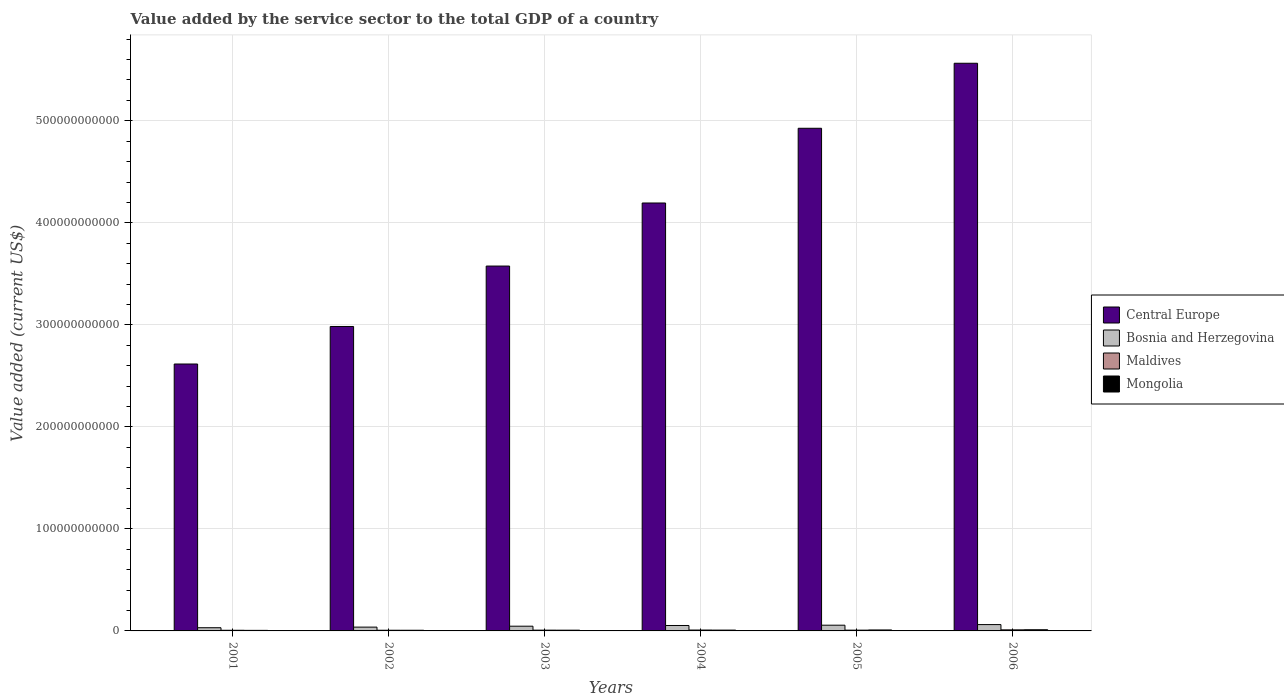How many groups of bars are there?
Your response must be concise. 6. Are the number of bars on each tick of the X-axis equal?
Your answer should be very brief. Yes. What is the label of the 6th group of bars from the left?
Give a very brief answer. 2006. What is the value added by the service sector to the total GDP in Bosnia and Herzegovina in 2003?
Your response must be concise. 4.64e+09. Across all years, what is the maximum value added by the service sector to the total GDP in Bosnia and Herzegovina?
Offer a very short reply. 6.21e+09. Across all years, what is the minimum value added by the service sector to the total GDP in Maldives?
Your response must be concise. 6.40e+08. What is the total value added by the service sector to the total GDP in Central Europe in the graph?
Your response must be concise. 2.39e+12. What is the difference between the value added by the service sector to the total GDP in Central Europe in 2003 and that in 2006?
Your response must be concise. -1.99e+11. What is the difference between the value added by the service sector to the total GDP in Central Europe in 2006 and the value added by the service sector to the total GDP in Mongolia in 2002?
Offer a very short reply. 5.56e+11. What is the average value added by the service sector to the total GDP in Bosnia and Herzegovina per year?
Your answer should be compact. 4.77e+09. In the year 2002, what is the difference between the value added by the service sector to the total GDP in Maldives and value added by the service sector to the total GDP in Mongolia?
Keep it short and to the point. 8.49e+06. In how many years, is the value added by the service sector to the total GDP in Maldives greater than 280000000000 US$?
Ensure brevity in your answer.  0. What is the ratio of the value added by the service sector to the total GDP in Maldives in 2003 to that in 2004?
Provide a succinct answer. 0.88. Is the value added by the service sector to the total GDP in Central Europe in 2005 less than that in 2006?
Provide a succinct answer. Yes. What is the difference between the highest and the second highest value added by the service sector to the total GDP in Mongolia?
Your response must be concise. 2.02e+08. What is the difference between the highest and the lowest value added by the service sector to the total GDP in Bosnia and Herzegovina?
Provide a short and direct response. 3.08e+09. In how many years, is the value added by the service sector to the total GDP in Maldives greater than the average value added by the service sector to the total GDP in Maldives taken over all years?
Ensure brevity in your answer.  2. What does the 2nd bar from the left in 2003 represents?
Keep it short and to the point. Bosnia and Herzegovina. What does the 2nd bar from the right in 2005 represents?
Your response must be concise. Maldives. How many bars are there?
Your answer should be compact. 24. Are all the bars in the graph horizontal?
Your answer should be very brief. No. What is the difference between two consecutive major ticks on the Y-axis?
Ensure brevity in your answer.  1.00e+11. Where does the legend appear in the graph?
Offer a terse response. Center right. How are the legend labels stacked?
Make the answer very short. Vertical. What is the title of the graph?
Provide a succinct answer. Value added by the service sector to the total GDP of a country. Does "Rwanda" appear as one of the legend labels in the graph?
Offer a very short reply. No. What is the label or title of the Y-axis?
Give a very brief answer. Value added (current US$). What is the Value added (current US$) in Central Europe in 2001?
Your answer should be compact. 2.62e+11. What is the Value added (current US$) in Bosnia and Herzegovina in 2001?
Your answer should be compact. 3.13e+09. What is the Value added (current US$) in Maldives in 2001?
Keep it short and to the point. 6.40e+08. What is the Value added (current US$) of Mongolia in 2001?
Provide a succinct answer. 5.36e+08. What is the Value added (current US$) of Central Europe in 2002?
Offer a very short reply. 2.98e+11. What is the Value added (current US$) in Bosnia and Herzegovina in 2002?
Your answer should be very brief. 3.72e+09. What is the Value added (current US$) in Maldives in 2002?
Give a very brief answer. 6.59e+08. What is the Value added (current US$) of Mongolia in 2002?
Give a very brief answer. 6.51e+08. What is the Value added (current US$) of Central Europe in 2003?
Your response must be concise. 3.58e+11. What is the Value added (current US$) in Bosnia and Herzegovina in 2003?
Provide a succinct answer. 4.64e+09. What is the Value added (current US$) of Maldives in 2003?
Your answer should be very brief. 7.62e+08. What is the Value added (current US$) in Mongolia in 2003?
Offer a very short reply. 7.20e+08. What is the Value added (current US$) in Central Europe in 2004?
Provide a short and direct response. 4.19e+11. What is the Value added (current US$) in Bosnia and Herzegovina in 2004?
Provide a succinct answer. 5.32e+09. What is the Value added (current US$) of Maldives in 2004?
Offer a very short reply. 8.68e+08. What is the Value added (current US$) of Mongolia in 2004?
Your response must be concise. 8.02e+08. What is the Value added (current US$) in Central Europe in 2005?
Provide a succinct answer. 4.93e+11. What is the Value added (current US$) of Bosnia and Herzegovina in 2005?
Give a very brief answer. 5.62e+09. What is the Value added (current US$) in Maldives in 2005?
Your response must be concise. 7.63e+08. What is the Value added (current US$) of Mongolia in 2005?
Offer a very short reply. 9.45e+08. What is the Value added (current US$) in Central Europe in 2006?
Keep it short and to the point. 5.56e+11. What is the Value added (current US$) in Bosnia and Herzegovina in 2006?
Provide a short and direct response. 6.21e+09. What is the Value added (current US$) of Maldives in 2006?
Keep it short and to the point. 1.04e+09. What is the Value added (current US$) in Mongolia in 2006?
Offer a terse response. 1.15e+09. Across all years, what is the maximum Value added (current US$) of Central Europe?
Give a very brief answer. 5.56e+11. Across all years, what is the maximum Value added (current US$) in Bosnia and Herzegovina?
Keep it short and to the point. 6.21e+09. Across all years, what is the maximum Value added (current US$) in Maldives?
Ensure brevity in your answer.  1.04e+09. Across all years, what is the maximum Value added (current US$) of Mongolia?
Give a very brief answer. 1.15e+09. Across all years, what is the minimum Value added (current US$) of Central Europe?
Provide a succinct answer. 2.62e+11. Across all years, what is the minimum Value added (current US$) of Bosnia and Herzegovina?
Provide a succinct answer. 3.13e+09. Across all years, what is the minimum Value added (current US$) in Maldives?
Give a very brief answer. 6.40e+08. Across all years, what is the minimum Value added (current US$) of Mongolia?
Offer a very short reply. 5.36e+08. What is the total Value added (current US$) in Central Europe in the graph?
Your answer should be very brief. 2.39e+12. What is the total Value added (current US$) in Bosnia and Herzegovina in the graph?
Your response must be concise. 2.86e+1. What is the total Value added (current US$) in Maldives in the graph?
Keep it short and to the point. 4.73e+09. What is the total Value added (current US$) of Mongolia in the graph?
Ensure brevity in your answer.  4.80e+09. What is the difference between the Value added (current US$) in Central Europe in 2001 and that in 2002?
Your answer should be very brief. -3.68e+1. What is the difference between the Value added (current US$) of Bosnia and Herzegovina in 2001 and that in 2002?
Make the answer very short. -5.90e+08. What is the difference between the Value added (current US$) in Maldives in 2001 and that in 2002?
Your answer should be compact. -1.97e+07. What is the difference between the Value added (current US$) in Mongolia in 2001 and that in 2002?
Offer a terse response. -1.15e+08. What is the difference between the Value added (current US$) of Central Europe in 2001 and that in 2003?
Make the answer very short. -9.60e+1. What is the difference between the Value added (current US$) in Bosnia and Herzegovina in 2001 and that in 2003?
Make the answer very short. -1.51e+09. What is the difference between the Value added (current US$) of Maldives in 2001 and that in 2003?
Keep it short and to the point. -1.22e+08. What is the difference between the Value added (current US$) of Mongolia in 2001 and that in 2003?
Provide a short and direct response. -1.85e+08. What is the difference between the Value added (current US$) in Central Europe in 2001 and that in 2004?
Provide a short and direct response. -1.58e+11. What is the difference between the Value added (current US$) of Bosnia and Herzegovina in 2001 and that in 2004?
Your response must be concise. -2.19e+09. What is the difference between the Value added (current US$) in Maldives in 2001 and that in 2004?
Keep it short and to the point. -2.28e+08. What is the difference between the Value added (current US$) in Mongolia in 2001 and that in 2004?
Your answer should be compact. -2.66e+08. What is the difference between the Value added (current US$) of Central Europe in 2001 and that in 2005?
Offer a terse response. -2.31e+11. What is the difference between the Value added (current US$) in Bosnia and Herzegovina in 2001 and that in 2005?
Your answer should be very brief. -2.49e+09. What is the difference between the Value added (current US$) of Maldives in 2001 and that in 2005?
Provide a succinct answer. -1.23e+08. What is the difference between the Value added (current US$) of Mongolia in 2001 and that in 2005?
Your answer should be very brief. -4.09e+08. What is the difference between the Value added (current US$) in Central Europe in 2001 and that in 2006?
Make the answer very short. -2.95e+11. What is the difference between the Value added (current US$) in Bosnia and Herzegovina in 2001 and that in 2006?
Offer a very short reply. -3.08e+09. What is the difference between the Value added (current US$) in Maldives in 2001 and that in 2006?
Give a very brief answer. -4.04e+08. What is the difference between the Value added (current US$) in Mongolia in 2001 and that in 2006?
Offer a very short reply. -6.11e+08. What is the difference between the Value added (current US$) in Central Europe in 2002 and that in 2003?
Your answer should be compact. -5.92e+1. What is the difference between the Value added (current US$) of Bosnia and Herzegovina in 2002 and that in 2003?
Your answer should be very brief. -9.15e+08. What is the difference between the Value added (current US$) in Maldives in 2002 and that in 2003?
Your answer should be compact. -1.03e+08. What is the difference between the Value added (current US$) of Mongolia in 2002 and that in 2003?
Make the answer very short. -6.96e+07. What is the difference between the Value added (current US$) in Central Europe in 2002 and that in 2004?
Offer a very short reply. -1.21e+11. What is the difference between the Value added (current US$) of Bosnia and Herzegovina in 2002 and that in 2004?
Give a very brief answer. -1.60e+09. What is the difference between the Value added (current US$) of Maldives in 2002 and that in 2004?
Your answer should be very brief. -2.08e+08. What is the difference between the Value added (current US$) of Mongolia in 2002 and that in 2004?
Give a very brief answer. -1.51e+08. What is the difference between the Value added (current US$) of Central Europe in 2002 and that in 2005?
Provide a short and direct response. -1.94e+11. What is the difference between the Value added (current US$) of Bosnia and Herzegovina in 2002 and that in 2005?
Offer a terse response. -1.90e+09. What is the difference between the Value added (current US$) in Maldives in 2002 and that in 2005?
Ensure brevity in your answer.  -1.04e+08. What is the difference between the Value added (current US$) in Mongolia in 2002 and that in 2005?
Ensure brevity in your answer.  -2.94e+08. What is the difference between the Value added (current US$) of Central Europe in 2002 and that in 2006?
Your response must be concise. -2.58e+11. What is the difference between the Value added (current US$) of Bosnia and Herzegovina in 2002 and that in 2006?
Your answer should be very brief. -2.49e+09. What is the difference between the Value added (current US$) in Maldives in 2002 and that in 2006?
Provide a short and direct response. -3.84e+08. What is the difference between the Value added (current US$) in Mongolia in 2002 and that in 2006?
Your answer should be very brief. -4.96e+08. What is the difference between the Value added (current US$) of Central Europe in 2003 and that in 2004?
Offer a very short reply. -6.18e+1. What is the difference between the Value added (current US$) in Bosnia and Herzegovina in 2003 and that in 2004?
Your answer should be very brief. -6.82e+08. What is the difference between the Value added (current US$) in Maldives in 2003 and that in 2004?
Offer a very short reply. -1.06e+08. What is the difference between the Value added (current US$) of Mongolia in 2003 and that in 2004?
Ensure brevity in your answer.  -8.12e+07. What is the difference between the Value added (current US$) in Central Europe in 2003 and that in 2005?
Ensure brevity in your answer.  -1.35e+11. What is the difference between the Value added (current US$) in Bosnia and Herzegovina in 2003 and that in 2005?
Your answer should be compact. -9.80e+08. What is the difference between the Value added (current US$) of Maldives in 2003 and that in 2005?
Make the answer very short. -9.74e+05. What is the difference between the Value added (current US$) of Mongolia in 2003 and that in 2005?
Ensure brevity in your answer.  -2.25e+08. What is the difference between the Value added (current US$) in Central Europe in 2003 and that in 2006?
Provide a short and direct response. -1.99e+11. What is the difference between the Value added (current US$) of Bosnia and Herzegovina in 2003 and that in 2006?
Make the answer very short. -1.57e+09. What is the difference between the Value added (current US$) in Maldives in 2003 and that in 2006?
Give a very brief answer. -2.82e+08. What is the difference between the Value added (current US$) in Mongolia in 2003 and that in 2006?
Your response must be concise. -4.27e+08. What is the difference between the Value added (current US$) in Central Europe in 2004 and that in 2005?
Offer a terse response. -7.32e+1. What is the difference between the Value added (current US$) in Bosnia and Herzegovina in 2004 and that in 2005?
Provide a short and direct response. -2.98e+08. What is the difference between the Value added (current US$) in Maldives in 2004 and that in 2005?
Offer a terse response. 1.05e+08. What is the difference between the Value added (current US$) of Mongolia in 2004 and that in 2005?
Offer a very short reply. -1.44e+08. What is the difference between the Value added (current US$) in Central Europe in 2004 and that in 2006?
Provide a short and direct response. -1.37e+11. What is the difference between the Value added (current US$) in Bosnia and Herzegovina in 2004 and that in 2006?
Your response must be concise. -8.92e+08. What is the difference between the Value added (current US$) in Maldives in 2004 and that in 2006?
Give a very brief answer. -1.76e+08. What is the difference between the Value added (current US$) of Mongolia in 2004 and that in 2006?
Your response must be concise. -3.46e+08. What is the difference between the Value added (current US$) in Central Europe in 2005 and that in 2006?
Provide a short and direct response. -6.37e+1. What is the difference between the Value added (current US$) of Bosnia and Herzegovina in 2005 and that in 2006?
Provide a succinct answer. -5.94e+08. What is the difference between the Value added (current US$) of Maldives in 2005 and that in 2006?
Offer a very short reply. -2.81e+08. What is the difference between the Value added (current US$) in Mongolia in 2005 and that in 2006?
Your answer should be compact. -2.02e+08. What is the difference between the Value added (current US$) of Central Europe in 2001 and the Value added (current US$) of Bosnia and Herzegovina in 2002?
Offer a terse response. 2.58e+11. What is the difference between the Value added (current US$) in Central Europe in 2001 and the Value added (current US$) in Maldives in 2002?
Provide a short and direct response. 2.61e+11. What is the difference between the Value added (current US$) in Central Europe in 2001 and the Value added (current US$) in Mongolia in 2002?
Make the answer very short. 2.61e+11. What is the difference between the Value added (current US$) in Bosnia and Herzegovina in 2001 and the Value added (current US$) in Maldives in 2002?
Your response must be concise. 2.47e+09. What is the difference between the Value added (current US$) of Bosnia and Herzegovina in 2001 and the Value added (current US$) of Mongolia in 2002?
Your response must be concise. 2.48e+09. What is the difference between the Value added (current US$) of Maldives in 2001 and the Value added (current US$) of Mongolia in 2002?
Keep it short and to the point. -1.12e+07. What is the difference between the Value added (current US$) of Central Europe in 2001 and the Value added (current US$) of Bosnia and Herzegovina in 2003?
Ensure brevity in your answer.  2.57e+11. What is the difference between the Value added (current US$) in Central Europe in 2001 and the Value added (current US$) in Maldives in 2003?
Make the answer very short. 2.61e+11. What is the difference between the Value added (current US$) of Central Europe in 2001 and the Value added (current US$) of Mongolia in 2003?
Provide a succinct answer. 2.61e+11. What is the difference between the Value added (current US$) in Bosnia and Herzegovina in 2001 and the Value added (current US$) in Maldives in 2003?
Keep it short and to the point. 2.37e+09. What is the difference between the Value added (current US$) in Bosnia and Herzegovina in 2001 and the Value added (current US$) in Mongolia in 2003?
Provide a succinct answer. 2.41e+09. What is the difference between the Value added (current US$) in Maldives in 2001 and the Value added (current US$) in Mongolia in 2003?
Make the answer very short. -8.08e+07. What is the difference between the Value added (current US$) of Central Europe in 2001 and the Value added (current US$) of Bosnia and Herzegovina in 2004?
Offer a very short reply. 2.56e+11. What is the difference between the Value added (current US$) of Central Europe in 2001 and the Value added (current US$) of Maldives in 2004?
Your answer should be compact. 2.61e+11. What is the difference between the Value added (current US$) in Central Europe in 2001 and the Value added (current US$) in Mongolia in 2004?
Your answer should be compact. 2.61e+11. What is the difference between the Value added (current US$) of Bosnia and Herzegovina in 2001 and the Value added (current US$) of Maldives in 2004?
Provide a short and direct response. 2.26e+09. What is the difference between the Value added (current US$) in Bosnia and Herzegovina in 2001 and the Value added (current US$) in Mongolia in 2004?
Your answer should be compact. 2.33e+09. What is the difference between the Value added (current US$) in Maldives in 2001 and the Value added (current US$) in Mongolia in 2004?
Keep it short and to the point. -1.62e+08. What is the difference between the Value added (current US$) of Central Europe in 2001 and the Value added (current US$) of Bosnia and Herzegovina in 2005?
Make the answer very short. 2.56e+11. What is the difference between the Value added (current US$) of Central Europe in 2001 and the Value added (current US$) of Maldives in 2005?
Provide a succinct answer. 2.61e+11. What is the difference between the Value added (current US$) in Central Europe in 2001 and the Value added (current US$) in Mongolia in 2005?
Your answer should be very brief. 2.61e+11. What is the difference between the Value added (current US$) in Bosnia and Herzegovina in 2001 and the Value added (current US$) in Maldives in 2005?
Your response must be concise. 2.37e+09. What is the difference between the Value added (current US$) of Bosnia and Herzegovina in 2001 and the Value added (current US$) of Mongolia in 2005?
Ensure brevity in your answer.  2.19e+09. What is the difference between the Value added (current US$) in Maldives in 2001 and the Value added (current US$) in Mongolia in 2005?
Your answer should be compact. -3.06e+08. What is the difference between the Value added (current US$) of Central Europe in 2001 and the Value added (current US$) of Bosnia and Herzegovina in 2006?
Provide a succinct answer. 2.55e+11. What is the difference between the Value added (current US$) of Central Europe in 2001 and the Value added (current US$) of Maldives in 2006?
Provide a succinct answer. 2.61e+11. What is the difference between the Value added (current US$) in Central Europe in 2001 and the Value added (current US$) in Mongolia in 2006?
Ensure brevity in your answer.  2.60e+11. What is the difference between the Value added (current US$) in Bosnia and Herzegovina in 2001 and the Value added (current US$) in Maldives in 2006?
Your answer should be compact. 2.09e+09. What is the difference between the Value added (current US$) in Bosnia and Herzegovina in 2001 and the Value added (current US$) in Mongolia in 2006?
Ensure brevity in your answer.  1.98e+09. What is the difference between the Value added (current US$) in Maldives in 2001 and the Value added (current US$) in Mongolia in 2006?
Make the answer very short. -5.08e+08. What is the difference between the Value added (current US$) in Central Europe in 2002 and the Value added (current US$) in Bosnia and Herzegovina in 2003?
Your answer should be very brief. 2.94e+11. What is the difference between the Value added (current US$) in Central Europe in 2002 and the Value added (current US$) in Maldives in 2003?
Your answer should be very brief. 2.98e+11. What is the difference between the Value added (current US$) in Central Europe in 2002 and the Value added (current US$) in Mongolia in 2003?
Provide a succinct answer. 2.98e+11. What is the difference between the Value added (current US$) in Bosnia and Herzegovina in 2002 and the Value added (current US$) in Maldives in 2003?
Keep it short and to the point. 2.96e+09. What is the difference between the Value added (current US$) in Bosnia and Herzegovina in 2002 and the Value added (current US$) in Mongolia in 2003?
Offer a very short reply. 3.00e+09. What is the difference between the Value added (current US$) in Maldives in 2002 and the Value added (current US$) in Mongolia in 2003?
Provide a succinct answer. -6.11e+07. What is the difference between the Value added (current US$) of Central Europe in 2002 and the Value added (current US$) of Bosnia and Herzegovina in 2004?
Give a very brief answer. 2.93e+11. What is the difference between the Value added (current US$) in Central Europe in 2002 and the Value added (current US$) in Maldives in 2004?
Ensure brevity in your answer.  2.98e+11. What is the difference between the Value added (current US$) in Central Europe in 2002 and the Value added (current US$) in Mongolia in 2004?
Provide a succinct answer. 2.98e+11. What is the difference between the Value added (current US$) in Bosnia and Herzegovina in 2002 and the Value added (current US$) in Maldives in 2004?
Ensure brevity in your answer.  2.85e+09. What is the difference between the Value added (current US$) of Bosnia and Herzegovina in 2002 and the Value added (current US$) of Mongolia in 2004?
Your answer should be very brief. 2.92e+09. What is the difference between the Value added (current US$) in Maldives in 2002 and the Value added (current US$) in Mongolia in 2004?
Your answer should be very brief. -1.42e+08. What is the difference between the Value added (current US$) of Central Europe in 2002 and the Value added (current US$) of Bosnia and Herzegovina in 2005?
Offer a terse response. 2.93e+11. What is the difference between the Value added (current US$) of Central Europe in 2002 and the Value added (current US$) of Maldives in 2005?
Make the answer very short. 2.98e+11. What is the difference between the Value added (current US$) in Central Europe in 2002 and the Value added (current US$) in Mongolia in 2005?
Your answer should be very brief. 2.97e+11. What is the difference between the Value added (current US$) of Bosnia and Herzegovina in 2002 and the Value added (current US$) of Maldives in 2005?
Your answer should be compact. 2.96e+09. What is the difference between the Value added (current US$) of Bosnia and Herzegovina in 2002 and the Value added (current US$) of Mongolia in 2005?
Make the answer very short. 2.78e+09. What is the difference between the Value added (current US$) of Maldives in 2002 and the Value added (current US$) of Mongolia in 2005?
Ensure brevity in your answer.  -2.86e+08. What is the difference between the Value added (current US$) of Central Europe in 2002 and the Value added (current US$) of Bosnia and Herzegovina in 2006?
Your answer should be very brief. 2.92e+11. What is the difference between the Value added (current US$) of Central Europe in 2002 and the Value added (current US$) of Maldives in 2006?
Ensure brevity in your answer.  2.97e+11. What is the difference between the Value added (current US$) in Central Europe in 2002 and the Value added (current US$) in Mongolia in 2006?
Your response must be concise. 2.97e+11. What is the difference between the Value added (current US$) of Bosnia and Herzegovina in 2002 and the Value added (current US$) of Maldives in 2006?
Ensure brevity in your answer.  2.68e+09. What is the difference between the Value added (current US$) in Bosnia and Herzegovina in 2002 and the Value added (current US$) in Mongolia in 2006?
Your response must be concise. 2.57e+09. What is the difference between the Value added (current US$) of Maldives in 2002 and the Value added (current US$) of Mongolia in 2006?
Keep it short and to the point. -4.88e+08. What is the difference between the Value added (current US$) of Central Europe in 2003 and the Value added (current US$) of Bosnia and Herzegovina in 2004?
Offer a very short reply. 3.52e+11. What is the difference between the Value added (current US$) in Central Europe in 2003 and the Value added (current US$) in Maldives in 2004?
Provide a succinct answer. 3.57e+11. What is the difference between the Value added (current US$) of Central Europe in 2003 and the Value added (current US$) of Mongolia in 2004?
Make the answer very short. 3.57e+11. What is the difference between the Value added (current US$) in Bosnia and Herzegovina in 2003 and the Value added (current US$) in Maldives in 2004?
Keep it short and to the point. 3.77e+09. What is the difference between the Value added (current US$) in Bosnia and Herzegovina in 2003 and the Value added (current US$) in Mongolia in 2004?
Your response must be concise. 3.84e+09. What is the difference between the Value added (current US$) in Maldives in 2003 and the Value added (current US$) in Mongolia in 2004?
Give a very brief answer. -3.98e+07. What is the difference between the Value added (current US$) in Central Europe in 2003 and the Value added (current US$) in Bosnia and Herzegovina in 2005?
Make the answer very short. 3.52e+11. What is the difference between the Value added (current US$) in Central Europe in 2003 and the Value added (current US$) in Maldives in 2005?
Provide a succinct answer. 3.57e+11. What is the difference between the Value added (current US$) in Central Europe in 2003 and the Value added (current US$) in Mongolia in 2005?
Give a very brief answer. 3.57e+11. What is the difference between the Value added (current US$) in Bosnia and Herzegovina in 2003 and the Value added (current US$) in Maldives in 2005?
Provide a short and direct response. 3.87e+09. What is the difference between the Value added (current US$) in Bosnia and Herzegovina in 2003 and the Value added (current US$) in Mongolia in 2005?
Keep it short and to the point. 3.69e+09. What is the difference between the Value added (current US$) in Maldives in 2003 and the Value added (current US$) in Mongolia in 2005?
Ensure brevity in your answer.  -1.83e+08. What is the difference between the Value added (current US$) in Central Europe in 2003 and the Value added (current US$) in Bosnia and Herzegovina in 2006?
Keep it short and to the point. 3.51e+11. What is the difference between the Value added (current US$) in Central Europe in 2003 and the Value added (current US$) in Maldives in 2006?
Your answer should be compact. 3.57e+11. What is the difference between the Value added (current US$) in Central Europe in 2003 and the Value added (current US$) in Mongolia in 2006?
Offer a very short reply. 3.56e+11. What is the difference between the Value added (current US$) of Bosnia and Herzegovina in 2003 and the Value added (current US$) of Maldives in 2006?
Offer a terse response. 3.59e+09. What is the difference between the Value added (current US$) of Bosnia and Herzegovina in 2003 and the Value added (current US$) of Mongolia in 2006?
Offer a terse response. 3.49e+09. What is the difference between the Value added (current US$) of Maldives in 2003 and the Value added (current US$) of Mongolia in 2006?
Make the answer very short. -3.85e+08. What is the difference between the Value added (current US$) of Central Europe in 2004 and the Value added (current US$) of Bosnia and Herzegovina in 2005?
Give a very brief answer. 4.14e+11. What is the difference between the Value added (current US$) in Central Europe in 2004 and the Value added (current US$) in Maldives in 2005?
Make the answer very short. 4.19e+11. What is the difference between the Value added (current US$) in Central Europe in 2004 and the Value added (current US$) in Mongolia in 2005?
Keep it short and to the point. 4.18e+11. What is the difference between the Value added (current US$) of Bosnia and Herzegovina in 2004 and the Value added (current US$) of Maldives in 2005?
Your response must be concise. 4.56e+09. What is the difference between the Value added (current US$) in Bosnia and Herzegovina in 2004 and the Value added (current US$) in Mongolia in 2005?
Your answer should be very brief. 4.37e+09. What is the difference between the Value added (current US$) in Maldives in 2004 and the Value added (current US$) in Mongolia in 2005?
Ensure brevity in your answer.  -7.75e+07. What is the difference between the Value added (current US$) of Central Europe in 2004 and the Value added (current US$) of Bosnia and Herzegovina in 2006?
Your answer should be very brief. 4.13e+11. What is the difference between the Value added (current US$) of Central Europe in 2004 and the Value added (current US$) of Maldives in 2006?
Make the answer very short. 4.18e+11. What is the difference between the Value added (current US$) of Central Europe in 2004 and the Value added (current US$) of Mongolia in 2006?
Provide a short and direct response. 4.18e+11. What is the difference between the Value added (current US$) of Bosnia and Herzegovina in 2004 and the Value added (current US$) of Maldives in 2006?
Keep it short and to the point. 4.28e+09. What is the difference between the Value added (current US$) in Bosnia and Herzegovina in 2004 and the Value added (current US$) in Mongolia in 2006?
Give a very brief answer. 4.17e+09. What is the difference between the Value added (current US$) of Maldives in 2004 and the Value added (current US$) of Mongolia in 2006?
Your answer should be very brief. -2.80e+08. What is the difference between the Value added (current US$) in Central Europe in 2005 and the Value added (current US$) in Bosnia and Herzegovina in 2006?
Your answer should be compact. 4.86e+11. What is the difference between the Value added (current US$) in Central Europe in 2005 and the Value added (current US$) in Maldives in 2006?
Provide a succinct answer. 4.92e+11. What is the difference between the Value added (current US$) in Central Europe in 2005 and the Value added (current US$) in Mongolia in 2006?
Give a very brief answer. 4.92e+11. What is the difference between the Value added (current US$) of Bosnia and Herzegovina in 2005 and the Value added (current US$) of Maldives in 2006?
Your answer should be very brief. 4.57e+09. What is the difference between the Value added (current US$) in Bosnia and Herzegovina in 2005 and the Value added (current US$) in Mongolia in 2006?
Give a very brief answer. 4.47e+09. What is the difference between the Value added (current US$) in Maldives in 2005 and the Value added (current US$) in Mongolia in 2006?
Keep it short and to the point. -3.84e+08. What is the average Value added (current US$) of Central Europe per year?
Keep it short and to the point. 3.98e+11. What is the average Value added (current US$) of Bosnia and Herzegovina per year?
Offer a very short reply. 4.77e+09. What is the average Value added (current US$) of Maldives per year?
Keep it short and to the point. 7.89e+08. What is the average Value added (current US$) in Mongolia per year?
Ensure brevity in your answer.  8.00e+08. In the year 2001, what is the difference between the Value added (current US$) of Central Europe and Value added (current US$) of Bosnia and Herzegovina?
Ensure brevity in your answer.  2.58e+11. In the year 2001, what is the difference between the Value added (current US$) in Central Europe and Value added (current US$) in Maldives?
Provide a succinct answer. 2.61e+11. In the year 2001, what is the difference between the Value added (current US$) of Central Europe and Value added (current US$) of Mongolia?
Your response must be concise. 2.61e+11. In the year 2001, what is the difference between the Value added (current US$) in Bosnia and Herzegovina and Value added (current US$) in Maldives?
Provide a succinct answer. 2.49e+09. In the year 2001, what is the difference between the Value added (current US$) in Bosnia and Herzegovina and Value added (current US$) in Mongolia?
Provide a short and direct response. 2.60e+09. In the year 2001, what is the difference between the Value added (current US$) in Maldives and Value added (current US$) in Mongolia?
Offer a terse response. 1.04e+08. In the year 2002, what is the difference between the Value added (current US$) of Central Europe and Value added (current US$) of Bosnia and Herzegovina?
Ensure brevity in your answer.  2.95e+11. In the year 2002, what is the difference between the Value added (current US$) of Central Europe and Value added (current US$) of Maldives?
Your answer should be very brief. 2.98e+11. In the year 2002, what is the difference between the Value added (current US$) of Central Europe and Value added (current US$) of Mongolia?
Your answer should be compact. 2.98e+11. In the year 2002, what is the difference between the Value added (current US$) in Bosnia and Herzegovina and Value added (current US$) in Maldives?
Give a very brief answer. 3.06e+09. In the year 2002, what is the difference between the Value added (current US$) of Bosnia and Herzegovina and Value added (current US$) of Mongolia?
Your response must be concise. 3.07e+09. In the year 2002, what is the difference between the Value added (current US$) in Maldives and Value added (current US$) in Mongolia?
Your response must be concise. 8.49e+06. In the year 2003, what is the difference between the Value added (current US$) of Central Europe and Value added (current US$) of Bosnia and Herzegovina?
Keep it short and to the point. 3.53e+11. In the year 2003, what is the difference between the Value added (current US$) in Central Europe and Value added (current US$) in Maldives?
Provide a short and direct response. 3.57e+11. In the year 2003, what is the difference between the Value added (current US$) in Central Europe and Value added (current US$) in Mongolia?
Your answer should be very brief. 3.57e+11. In the year 2003, what is the difference between the Value added (current US$) in Bosnia and Herzegovina and Value added (current US$) in Maldives?
Provide a succinct answer. 3.88e+09. In the year 2003, what is the difference between the Value added (current US$) in Bosnia and Herzegovina and Value added (current US$) in Mongolia?
Give a very brief answer. 3.92e+09. In the year 2003, what is the difference between the Value added (current US$) of Maldives and Value added (current US$) of Mongolia?
Your answer should be compact. 4.14e+07. In the year 2004, what is the difference between the Value added (current US$) of Central Europe and Value added (current US$) of Bosnia and Herzegovina?
Make the answer very short. 4.14e+11. In the year 2004, what is the difference between the Value added (current US$) of Central Europe and Value added (current US$) of Maldives?
Keep it short and to the point. 4.19e+11. In the year 2004, what is the difference between the Value added (current US$) of Central Europe and Value added (current US$) of Mongolia?
Keep it short and to the point. 4.19e+11. In the year 2004, what is the difference between the Value added (current US$) of Bosnia and Herzegovina and Value added (current US$) of Maldives?
Offer a very short reply. 4.45e+09. In the year 2004, what is the difference between the Value added (current US$) in Bosnia and Herzegovina and Value added (current US$) in Mongolia?
Ensure brevity in your answer.  4.52e+09. In the year 2004, what is the difference between the Value added (current US$) in Maldives and Value added (current US$) in Mongolia?
Offer a terse response. 6.61e+07. In the year 2005, what is the difference between the Value added (current US$) of Central Europe and Value added (current US$) of Bosnia and Herzegovina?
Keep it short and to the point. 4.87e+11. In the year 2005, what is the difference between the Value added (current US$) of Central Europe and Value added (current US$) of Maldives?
Offer a terse response. 4.92e+11. In the year 2005, what is the difference between the Value added (current US$) in Central Europe and Value added (current US$) in Mongolia?
Provide a short and direct response. 4.92e+11. In the year 2005, what is the difference between the Value added (current US$) of Bosnia and Herzegovina and Value added (current US$) of Maldives?
Your answer should be compact. 4.85e+09. In the year 2005, what is the difference between the Value added (current US$) in Bosnia and Herzegovina and Value added (current US$) in Mongolia?
Make the answer very short. 4.67e+09. In the year 2005, what is the difference between the Value added (current US$) in Maldives and Value added (current US$) in Mongolia?
Provide a short and direct response. -1.82e+08. In the year 2006, what is the difference between the Value added (current US$) in Central Europe and Value added (current US$) in Bosnia and Herzegovina?
Your answer should be compact. 5.50e+11. In the year 2006, what is the difference between the Value added (current US$) in Central Europe and Value added (current US$) in Maldives?
Provide a short and direct response. 5.55e+11. In the year 2006, what is the difference between the Value added (current US$) of Central Europe and Value added (current US$) of Mongolia?
Ensure brevity in your answer.  5.55e+11. In the year 2006, what is the difference between the Value added (current US$) of Bosnia and Herzegovina and Value added (current US$) of Maldives?
Your answer should be compact. 5.17e+09. In the year 2006, what is the difference between the Value added (current US$) in Bosnia and Herzegovina and Value added (current US$) in Mongolia?
Keep it short and to the point. 5.06e+09. In the year 2006, what is the difference between the Value added (current US$) of Maldives and Value added (current US$) of Mongolia?
Provide a succinct answer. -1.04e+08. What is the ratio of the Value added (current US$) of Central Europe in 2001 to that in 2002?
Keep it short and to the point. 0.88. What is the ratio of the Value added (current US$) of Bosnia and Herzegovina in 2001 to that in 2002?
Offer a very short reply. 0.84. What is the ratio of the Value added (current US$) in Maldives in 2001 to that in 2002?
Offer a very short reply. 0.97. What is the ratio of the Value added (current US$) of Mongolia in 2001 to that in 2002?
Ensure brevity in your answer.  0.82. What is the ratio of the Value added (current US$) in Central Europe in 2001 to that in 2003?
Give a very brief answer. 0.73. What is the ratio of the Value added (current US$) of Bosnia and Herzegovina in 2001 to that in 2003?
Make the answer very short. 0.68. What is the ratio of the Value added (current US$) of Maldives in 2001 to that in 2003?
Your answer should be very brief. 0.84. What is the ratio of the Value added (current US$) in Mongolia in 2001 to that in 2003?
Provide a succinct answer. 0.74. What is the ratio of the Value added (current US$) in Central Europe in 2001 to that in 2004?
Offer a very short reply. 0.62. What is the ratio of the Value added (current US$) in Bosnia and Herzegovina in 2001 to that in 2004?
Your response must be concise. 0.59. What is the ratio of the Value added (current US$) of Maldives in 2001 to that in 2004?
Offer a terse response. 0.74. What is the ratio of the Value added (current US$) in Mongolia in 2001 to that in 2004?
Provide a short and direct response. 0.67. What is the ratio of the Value added (current US$) in Central Europe in 2001 to that in 2005?
Your answer should be very brief. 0.53. What is the ratio of the Value added (current US$) of Bosnia and Herzegovina in 2001 to that in 2005?
Provide a succinct answer. 0.56. What is the ratio of the Value added (current US$) of Maldives in 2001 to that in 2005?
Ensure brevity in your answer.  0.84. What is the ratio of the Value added (current US$) of Mongolia in 2001 to that in 2005?
Offer a very short reply. 0.57. What is the ratio of the Value added (current US$) of Central Europe in 2001 to that in 2006?
Your answer should be compact. 0.47. What is the ratio of the Value added (current US$) in Bosnia and Herzegovina in 2001 to that in 2006?
Offer a terse response. 0.5. What is the ratio of the Value added (current US$) in Maldives in 2001 to that in 2006?
Keep it short and to the point. 0.61. What is the ratio of the Value added (current US$) of Mongolia in 2001 to that in 2006?
Give a very brief answer. 0.47. What is the ratio of the Value added (current US$) of Central Europe in 2002 to that in 2003?
Keep it short and to the point. 0.83. What is the ratio of the Value added (current US$) in Bosnia and Herzegovina in 2002 to that in 2003?
Ensure brevity in your answer.  0.8. What is the ratio of the Value added (current US$) of Maldives in 2002 to that in 2003?
Give a very brief answer. 0.87. What is the ratio of the Value added (current US$) of Mongolia in 2002 to that in 2003?
Provide a succinct answer. 0.9. What is the ratio of the Value added (current US$) in Central Europe in 2002 to that in 2004?
Offer a very short reply. 0.71. What is the ratio of the Value added (current US$) of Bosnia and Herzegovina in 2002 to that in 2004?
Give a very brief answer. 0.7. What is the ratio of the Value added (current US$) in Maldives in 2002 to that in 2004?
Offer a terse response. 0.76. What is the ratio of the Value added (current US$) of Mongolia in 2002 to that in 2004?
Provide a succinct answer. 0.81. What is the ratio of the Value added (current US$) in Central Europe in 2002 to that in 2005?
Keep it short and to the point. 0.61. What is the ratio of the Value added (current US$) in Bosnia and Herzegovina in 2002 to that in 2005?
Offer a terse response. 0.66. What is the ratio of the Value added (current US$) in Maldives in 2002 to that in 2005?
Provide a succinct answer. 0.86. What is the ratio of the Value added (current US$) in Mongolia in 2002 to that in 2005?
Offer a very short reply. 0.69. What is the ratio of the Value added (current US$) in Central Europe in 2002 to that in 2006?
Your answer should be very brief. 0.54. What is the ratio of the Value added (current US$) in Bosnia and Herzegovina in 2002 to that in 2006?
Offer a terse response. 0.6. What is the ratio of the Value added (current US$) of Maldives in 2002 to that in 2006?
Your response must be concise. 0.63. What is the ratio of the Value added (current US$) of Mongolia in 2002 to that in 2006?
Keep it short and to the point. 0.57. What is the ratio of the Value added (current US$) in Central Europe in 2003 to that in 2004?
Your response must be concise. 0.85. What is the ratio of the Value added (current US$) of Bosnia and Herzegovina in 2003 to that in 2004?
Offer a terse response. 0.87. What is the ratio of the Value added (current US$) in Maldives in 2003 to that in 2004?
Keep it short and to the point. 0.88. What is the ratio of the Value added (current US$) of Mongolia in 2003 to that in 2004?
Make the answer very short. 0.9. What is the ratio of the Value added (current US$) of Central Europe in 2003 to that in 2005?
Give a very brief answer. 0.73. What is the ratio of the Value added (current US$) of Bosnia and Herzegovina in 2003 to that in 2005?
Your response must be concise. 0.83. What is the ratio of the Value added (current US$) of Maldives in 2003 to that in 2005?
Keep it short and to the point. 1. What is the ratio of the Value added (current US$) in Mongolia in 2003 to that in 2005?
Give a very brief answer. 0.76. What is the ratio of the Value added (current US$) in Central Europe in 2003 to that in 2006?
Offer a terse response. 0.64. What is the ratio of the Value added (current US$) in Bosnia and Herzegovina in 2003 to that in 2006?
Keep it short and to the point. 0.75. What is the ratio of the Value added (current US$) of Maldives in 2003 to that in 2006?
Your answer should be compact. 0.73. What is the ratio of the Value added (current US$) in Mongolia in 2003 to that in 2006?
Ensure brevity in your answer.  0.63. What is the ratio of the Value added (current US$) in Central Europe in 2004 to that in 2005?
Your answer should be very brief. 0.85. What is the ratio of the Value added (current US$) in Bosnia and Herzegovina in 2004 to that in 2005?
Offer a very short reply. 0.95. What is the ratio of the Value added (current US$) in Maldives in 2004 to that in 2005?
Your answer should be compact. 1.14. What is the ratio of the Value added (current US$) in Mongolia in 2004 to that in 2005?
Ensure brevity in your answer.  0.85. What is the ratio of the Value added (current US$) of Central Europe in 2004 to that in 2006?
Provide a succinct answer. 0.75. What is the ratio of the Value added (current US$) in Bosnia and Herzegovina in 2004 to that in 2006?
Make the answer very short. 0.86. What is the ratio of the Value added (current US$) of Maldives in 2004 to that in 2006?
Your answer should be compact. 0.83. What is the ratio of the Value added (current US$) of Mongolia in 2004 to that in 2006?
Make the answer very short. 0.7. What is the ratio of the Value added (current US$) in Central Europe in 2005 to that in 2006?
Your answer should be compact. 0.89. What is the ratio of the Value added (current US$) of Bosnia and Herzegovina in 2005 to that in 2006?
Keep it short and to the point. 0.9. What is the ratio of the Value added (current US$) in Maldives in 2005 to that in 2006?
Your answer should be very brief. 0.73. What is the ratio of the Value added (current US$) in Mongolia in 2005 to that in 2006?
Give a very brief answer. 0.82. What is the difference between the highest and the second highest Value added (current US$) in Central Europe?
Provide a short and direct response. 6.37e+1. What is the difference between the highest and the second highest Value added (current US$) of Bosnia and Herzegovina?
Your answer should be very brief. 5.94e+08. What is the difference between the highest and the second highest Value added (current US$) of Maldives?
Your response must be concise. 1.76e+08. What is the difference between the highest and the second highest Value added (current US$) of Mongolia?
Provide a succinct answer. 2.02e+08. What is the difference between the highest and the lowest Value added (current US$) of Central Europe?
Ensure brevity in your answer.  2.95e+11. What is the difference between the highest and the lowest Value added (current US$) in Bosnia and Herzegovina?
Make the answer very short. 3.08e+09. What is the difference between the highest and the lowest Value added (current US$) in Maldives?
Offer a terse response. 4.04e+08. What is the difference between the highest and the lowest Value added (current US$) in Mongolia?
Provide a succinct answer. 6.11e+08. 